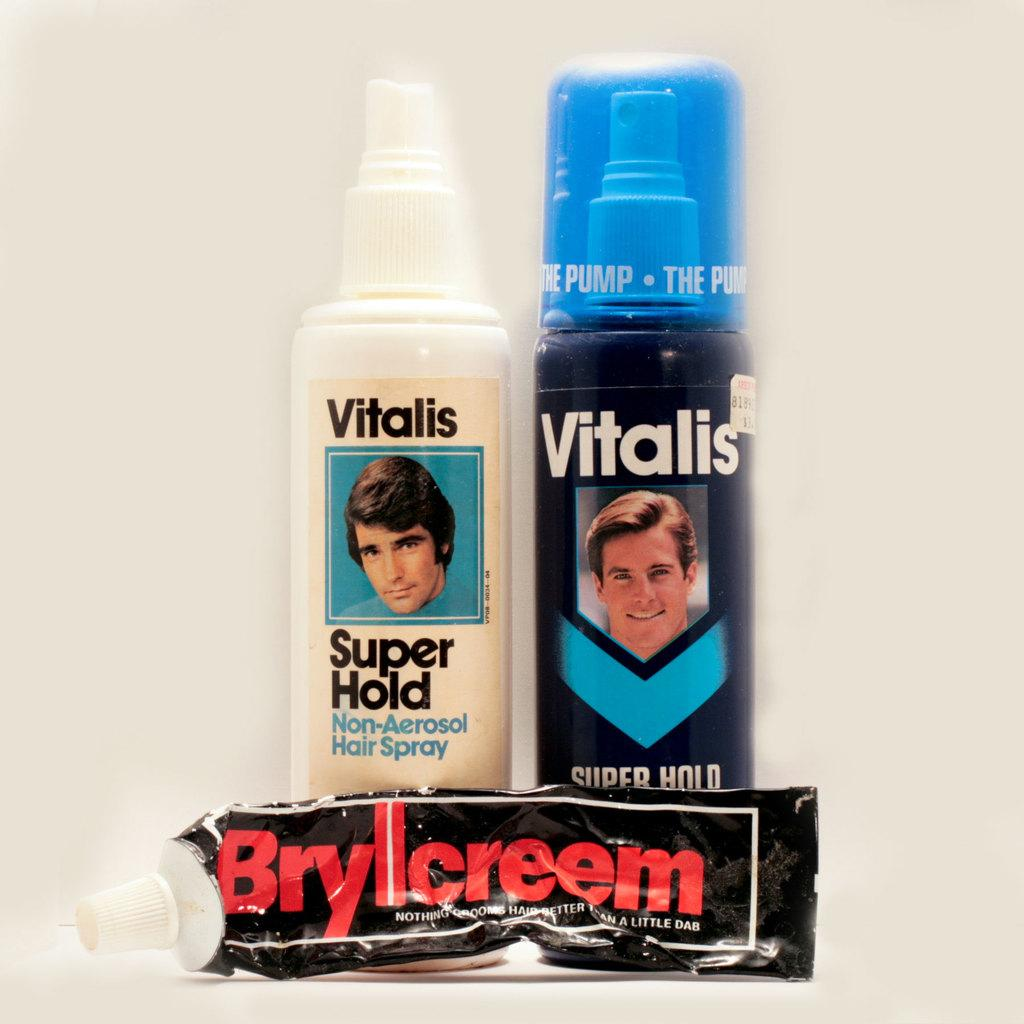<image>
Summarize the visual content of the image. A group of three hair products, two of which are Vitalis brand. 